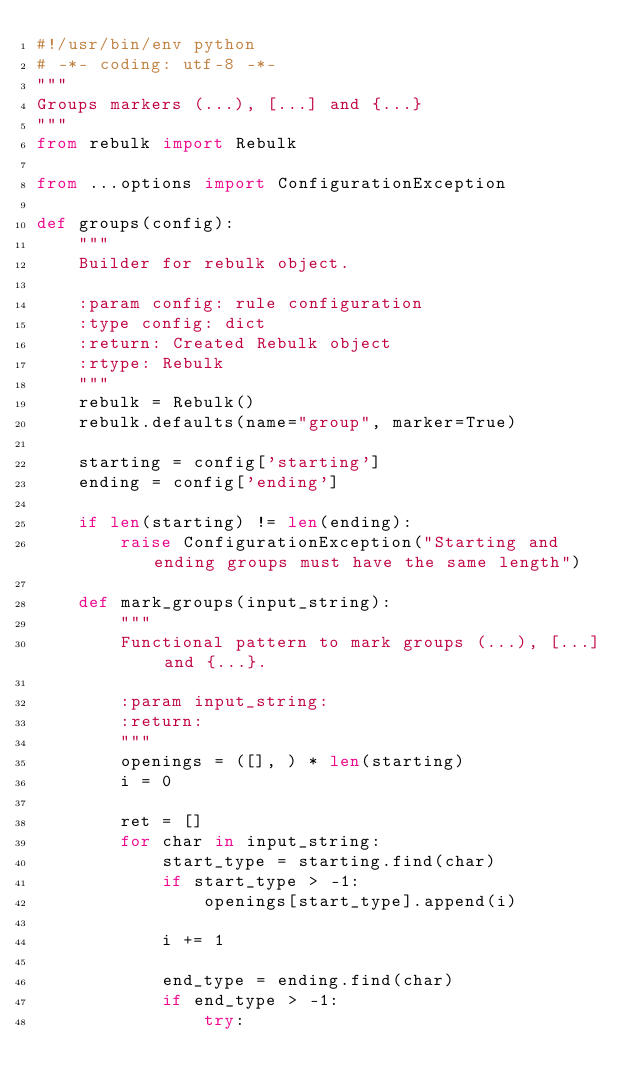<code> <loc_0><loc_0><loc_500><loc_500><_Python_>#!/usr/bin/env python
# -*- coding: utf-8 -*-
"""
Groups markers (...), [...] and {...}
"""
from rebulk import Rebulk

from ...options import ConfigurationException

def groups(config):
    """
    Builder for rebulk object.

    :param config: rule configuration
    :type config: dict
    :return: Created Rebulk object
    :rtype: Rebulk
    """
    rebulk = Rebulk()
    rebulk.defaults(name="group", marker=True)

    starting = config['starting']
    ending = config['ending']

    if len(starting) != len(ending):
        raise ConfigurationException("Starting and ending groups must have the same length")

    def mark_groups(input_string):
        """
        Functional pattern to mark groups (...), [...] and {...}.

        :param input_string:
        :return:
        """
        openings = ([], ) * len(starting)
        i = 0

        ret = []
        for char in input_string:
            start_type = starting.find(char)
            if start_type > -1:
                openings[start_type].append(i)

            i += 1

            end_type = ending.find(char)
            if end_type > -1:
                try:</code> 